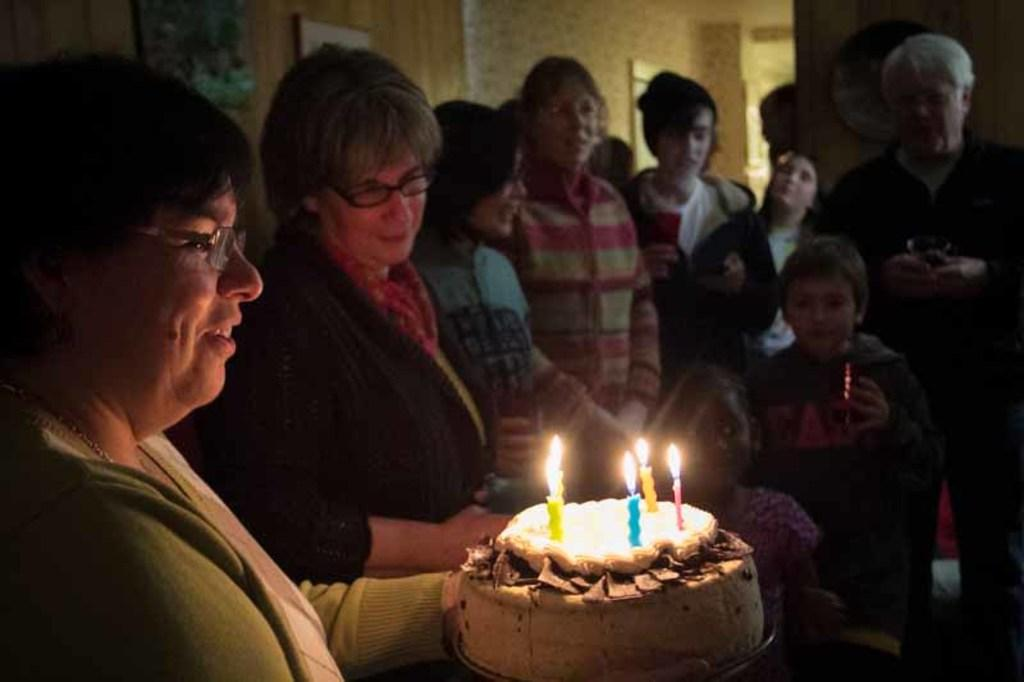How many people are in the image? There is a group of people in the image. What is the person holding in the image? The person is holding a cake with five candles on it. What can be seen on the wall in the background of the image? There are frames attached to the wall in the background of the image. Can you see any fish swimming in the image? There are no fish visible in the image. 